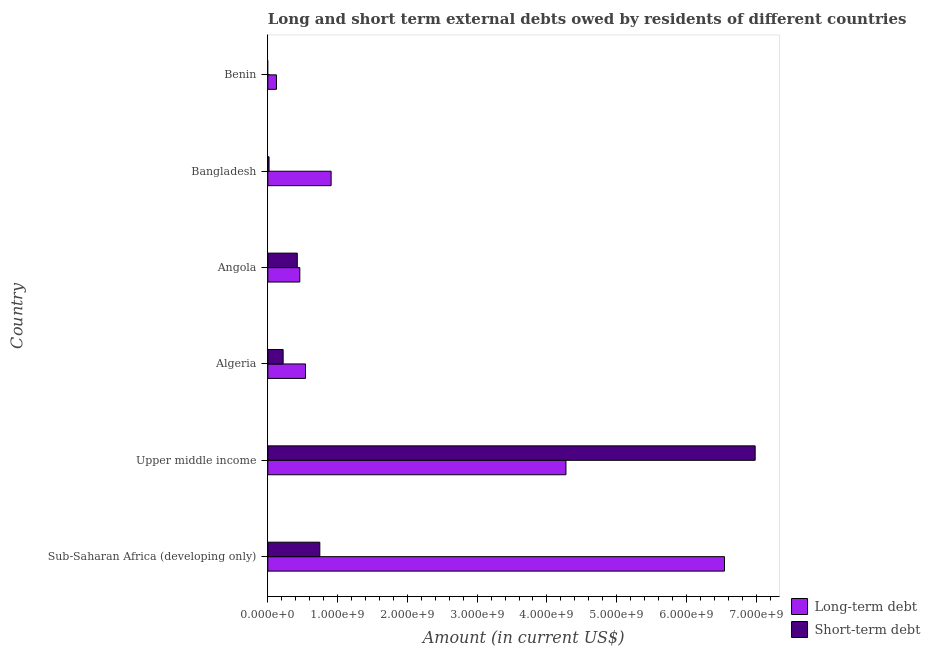How many different coloured bars are there?
Provide a short and direct response. 2. Are the number of bars per tick equal to the number of legend labels?
Make the answer very short. No. Are the number of bars on each tick of the Y-axis equal?
Your answer should be compact. No. How many bars are there on the 3rd tick from the bottom?
Provide a short and direct response. 2. What is the label of the 6th group of bars from the top?
Offer a very short reply. Sub-Saharan Africa (developing only). In how many cases, is the number of bars for a given country not equal to the number of legend labels?
Offer a terse response. 1. What is the short-term debts owed by residents in Angola?
Provide a short and direct response. 4.22e+08. Across all countries, what is the maximum short-term debts owed by residents?
Provide a succinct answer. 6.99e+09. Across all countries, what is the minimum long-term debts owed by residents?
Offer a terse response. 1.24e+08. In which country was the short-term debts owed by residents maximum?
Your response must be concise. Upper middle income. What is the total long-term debts owed by residents in the graph?
Provide a short and direct response. 1.28e+1. What is the difference between the long-term debts owed by residents in Bangladesh and that in Sub-Saharan Africa (developing only)?
Your response must be concise. -5.64e+09. What is the difference between the short-term debts owed by residents in Sub-Saharan Africa (developing only) and the long-term debts owed by residents in Benin?
Give a very brief answer. 6.21e+08. What is the average short-term debts owed by residents per country?
Make the answer very short. 1.40e+09. What is the difference between the long-term debts owed by residents and short-term debts owed by residents in Bangladesh?
Provide a short and direct response. 8.90e+08. What is the ratio of the long-term debts owed by residents in Bangladesh to that in Sub-Saharan Africa (developing only)?
Ensure brevity in your answer.  0.14. Is the difference between the long-term debts owed by residents in Angola and Bangladesh greater than the difference between the short-term debts owed by residents in Angola and Bangladesh?
Your answer should be very brief. No. What is the difference between the highest and the second highest short-term debts owed by residents?
Offer a very short reply. 6.24e+09. What is the difference between the highest and the lowest long-term debts owed by residents?
Offer a very short reply. 6.42e+09. In how many countries, is the short-term debts owed by residents greater than the average short-term debts owed by residents taken over all countries?
Ensure brevity in your answer.  1. Is the sum of the long-term debts owed by residents in Benin and Sub-Saharan Africa (developing only) greater than the maximum short-term debts owed by residents across all countries?
Your answer should be very brief. No. Are all the bars in the graph horizontal?
Your answer should be very brief. Yes. How many countries are there in the graph?
Offer a very short reply. 6. Does the graph contain any zero values?
Give a very brief answer. Yes. Where does the legend appear in the graph?
Make the answer very short. Bottom right. How many legend labels are there?
Your answer should be very brief. 2. What is the title of the graph?
Offer a very short reply. Long and short term external debts owed by residents of different countries. What is the Amount (in current US$) in Long-term debt in Sub-Saharan Africa (developing only)?
Give a very brief answer. 6.55e+09. What is the Amount (in current US$) in Short-term debt in Sub-Saharan Africa (developing only)?
Ensure brevity in your answer.  7.45e+08. What is the Amount (in current US$) of Long-term debt in Upper middle income?
Make the answer very short. 4.27e+09. What is the Amount (in current US$) in Short-term debt in Upper middle income?
Ensure brevity in your answer.  6.99e+09. What is the Amount (in current US$) in Long-term debt in Algeria?
Give a very brief answer. 5.39e+08. What is the Amount (in current US$) in Short-term debt in Algeria?
Your answer should be compact. 2.19e+08. What is the Amount (in current US$) in Long-term debt in Angola?
Make the answer very short. 4.58e+08. What is the Amount (in current US$) of Short-term debt in Angola?
Ensure brevity in your answer.  4.22e+08. What is the Amount (in current US$) in Long-term debt in Bangladesh?
Your answer should be compact. 9.07e+08. What is the Amount (in current US$) in Short-term debt in Bangladesh?
Offer a very short reply. 1.72e+07. What is the Amount (in current US$) in Long-term debt in Benin?
Offer a very short reply. 1.24e+08. What is the Amount (in current US$) in Short-term debt in Benin?
Make the answer very short. 0. Across all countries, what is the maximum Amount (in current US$) in Long-term debt?
Your answer should be compact. 6.55e+09. Across all countries, what is the maximum Amount (in current US$) in Short-term debt?
Your answer should be compact. 6.99e+09. Across all countries, what is the minimum Amount (in current US$) of Long-term debt?
Offer a very short reply. 1.24e+08. What is the total Amount (in current US$) of Long-term debt in the graph?
Keep it short and to the point. 1.28e+1. What is the total Amount (in current US$) in Short-term debt in the graph?
Your answer should be very brief. 8.39e+09. What is the difference between the Amount (in current US$) in Long-term debt in Sub-Saharan Africa (developing only) and that in Upper middle income?
Provide a short and direct response. 2.27e+09. What is the difference between the Amount (in current US$) of Short-term debt in Sub-Saharan Africa (developing only) and that in Upper middle income?
Offer a very short reply. -6.24e+09. What is the difference between the Amount (in current US$) in Long-term debt in Sub-Saharan Africa (developing only) and that in Algeria?
Give a very brief answer. 6.01e+09. What is the difference between the Amount (in current US$) of Short-term debt in Sub-Saharan Africa (developing only) and that in Algeria?
Give a very brief answer. 5.26e+08. What is the difference between the Amount (in current US$) in Long-term debt in Sub-Saharan Africa (developing only) and that in Angola?
Give a very brief answer. 6.09e+09. What is the difference between the Amount (in current US$) in Short-term debt in Sub-Saharan Africa (developing only) and that in Angola?
Your answer should be compact. 3.23e+08. What is the difference between the Amount (in current US$) of Long-term debt in Sub-Saharan Africa (developing only) and that in Bangladesh?
Your answer should be very brief. 5.64e+09. What is the difference between the Amount (in current US$) of Short-term debt in Sub-Saharan Africa (developing only) and that in Bangladesh?
Ensure brevity in your answer.  7.28e+08. What is the difference between the Amount (in current US$) of Long-term debt in Sub-Saharan Africa (developing only) and that in Benin?
Offer a very short reply. 6.42e+09. What is the difference between the Amount (in current US$) of Long-term debt in Upper middle income and that in Algeria?
Provide a succinct answer. 3.73e+09. What is the difference between the Amount (in current US$) in Short-term debt in Upper middle income and that in Algeria?
Offer a terse response. 6.77e+09. What is the difference between the Amount (in current US$) in Long-term debt in Upper middle income and that in Angola?
Offer a very short reply. 3.81e+09. What is the difference between the Amount (in current US$) in Short-term debt in Upper middle income and that in Angola?
Your answer should be compact. 6.56e+09. What is the difference between the Amount (in current US$) in Long-term debt in Upper middle income and that in Bangladesh?
Your answer should be compact. 3.37e+09. What is the difference between the Amount (in current US$) in Short-term debt in Upper middle income and that in Bangladesh?
Offer a terse response. 6.97e+09. What is the difference between the Amount (in current US$) of Long-term debt in Upper middle income and that in Benin?
Your answer should be compact. 4.15e+09. What is the difference between the Amount (in current US$) in Long-term debt in Algeria and that in Angola?
Your answer should be compact. 8.13e+07. What is the difference between the Amount (in current US$) in Short-term debt in Algeria and that in Angola?
Provide a short and direct response. -2.03e+08. What is the difference between the Amount (in current US$) in Long-term debt in Algeria and that in Bangladesh?
Offer a very short reply. -3.68e+08. What is the difference between the Amount (in current US$) in Short-term debt in Algeria and that in Bangladesh?
Make the answer very short. 2.02e+08. What is the difference between the Amount (in current US$) in Long-term debt in Algeria and that in Benin?
Give a very brief answer. 4.16e+08. What is the difference between the Amount (in current US$) in Long-term debt in Angola and that in Bangladesh?
Provide a short and direct response. -4.49e+08. What is the difference between the Amount (in current US$) in Short-term debt in Angola and that in Bangladesh?
Ensure brevity in your answer.  4.05e+08. What is the difference between the Amount (in current US$) in Long-term debt in Angola and that in Benin?
Keep it short and to the point. 3.35e+08. What is the difference between the Amount (in current US$) of Long-term debt in Bangladesh and that in Benin?
Provide a succinct answer. 7.83e+08. What is the difference between the Amount (in current US$) in Long-term debt in Sub-Saharan Africa (developing only) and the Amount (in current US$) in Short-term debt in Upper middle income?
Keep it short and to the point. -4.40e+08. What is the difference between the Amount (in current US$) of Long-term debt in Sub-Saharan Africa (developing only) and the Amount (in current US$) of Short-term debt in Algeria?
Make the answer very short. 6.33e+09. What is the difference between the Amount (in current US$) of Long-term debt in Sub-Saharan Africa (developing only) and the Amount (in current US$) of Short-term debt in Angola?
Provide a succinct answer. 6.12e+09. What is the difference between the Amount (in current US$) in Long-term debt in Sub-Saharan Africa (developing only) and the Amount (in current US$) in Short-term debt in Bangladesh?
Ensure brevity in your answer.  6.53e+09. What is the difference between the Amount (in current US$) in Long-term debt in Upper middle income and the Amount (in current US$) in Short-term debt in Algeria?
Your answer should be compact. 4.05e+09. What is the difference between the Amount (in current US$) of Long-term debt in Upper middle income and the Amount (in current US$) of Short-term debt in Angola?
Make the answer very short. 3.85e+09. What is the difference between the Amount (in current US$) of Long-term debt in Upper middle income and the Amount (in current US$) of Short-term debt in Bangladesh?
Make the answer very short. 4.26e+09. What is the difference between the Amount (in current US$) in Long-term debt in Algeria and the Amount (in current US$) in Short-term debt in Angola?
Provide a short and direct response. 1.17e+08. What is the difference between the Amount (in current US$) of Long-term debt in Algeria and the Amount (in current US$) of Short-term debt in Bangladesh?
Provide a short and direct response. 5.22e+08. What is the difference between the Amount (in current US$) in Long-term debt in Angola and the Amount (in current US$) in Short-term debt in Bangladesh?
Offer a very short reply. 4.41e+08. What is the average Amount (in current US$) in Long-term debt per country?
Offer a terse response. 2.14e+09. What is the average Amount (in current US$) in Short-term debt per country?
Offer a terse response. 1.40e+09. What is the difference between the Amount (in current US$) in Long-term debt and Amount (in current US$) in Short-term debt in Sub-Saharan Africa (developing only)?
Ensure brevity in your answer.  5.80e+09. What is the difference between the Amount (in current US$) in Long-term debt and Amount (in current US$) in Short-term debt in Upper middle income?
Provide a short and direct response. -2.71e+09. What is the difference between the Amount (in current US$) in Long-term debt and Amount (in current US$) in Short-term debt in Algeria?
Keep it short and to the point. 3.20e+08. What is the difference between the Amount (in current US$) in Long-term debt and Amount (in current US$) in Short-term debt in Angola?
Your response must be concise. 3.62e+07. What is the difference between the Amount (in current US$) in Long-term debt and Amount (in current US$) in Short-term debt in Bangladesh?
Keep it short and to the point. 8.90e+08. What is the ratio of the Amount (in current US$) in Long-term debt in Sub-Saharan Africa (developing only) to that in Upper middle income?
Your answer should be compact. 1.53. What is the ratio of the Amount (in current US$) of Short-term debt in Sub-Saharan Africa (developing only) to that in Upper middle income?
Offer a terse response. 0.11. What is the ratio of the Amount (in current US$) of Long-term debt in Sub-Saharan Africa (developing only) to that in Algeria?
Offer a terse response. 12.13. What is the ratio of the Amount (in current US$) in Short-term debt in Sub-Saharan Africa (developing only) to that in Algeria?
Provide a short and direct response. 3.4. What is the ratio of the Amount (in current US$) of Long-term debt in Sub-Saharan Africa (developing only) to that in Angola?
Give a very brief answer. 14.29. What is the ratio of the Amount (in current US$) in Short-term debt in Sub-Saharan Africa (developing only) to that in Angola?
Provide a short and direct response. 1.77. What is the ratio of the Amount (in current US$) in Long-term debt in Sub-Saharan Africa (developing only) to that in Bangladesh?
Provide a short and direct response. 7.22. What is the ratio of the Amount (in current US$) of Short-term debt in Sub-Saharan Africa (developing only) to that in Bangladesh?
Offer a terse response. 43.39. What is the ratio of the Amount (in current US$) of Long-term debt in Sub-Saharan Africa (developing only) to that in Benin?
Keep it short and to the point. 52.98. What is the ratio of the Amount (in current US$) of Long-term debt in Upper middle income to that in Algeria?
Offer a terse response. 7.92. What is the ratio of the Amount (in current US$) of Short-term debt in Upper middle income to that in Algeria?
Offer a terse response. 31.87. What is the ratio of the Amount (in current US$) in Long-term debt in Upper middle income to that in Angola?
Ensure brevity in your answer.  9.33. What is the ratio of the Amount (in current US$) of Short-term debt in Upper middle income to that in Angola?
Make the answer very short. 16.55. What is the ratio of the Amount (in current US$) in Long-term debt in Upper middle income to that in Bangladesh?
Keep it short and to the point. 4.71. What is the ratio of the Amount (in current US$) in Short-term debt in Upper middle income to that in Bangladesh?
Make the answer very short. 406.82. What is the ratio of the Amount (in current US$) of Long-term debt in Upper middle income to that in Benin?
Provide a short and direct response. 34.59. What is the ratio of the Amount (in current US$) of Long-term debt in Algeria to that in Angola?
Offer a terse response. 1.18. What is the ratio of the Amount (in current US$) of Short-term debt in Algeria to that in Angola?
Offer a very short reply. 0.52. What is the ratio of the Amount (in current US$) in Long-term debt in Algeria to that in Bangladesh?
Make the answer very short. 0.59. What is the ratio of the Amount (in current US$) of Short-term debt in Algeria to that in Bangladesh?
Make the answer very short. 12.77. What is the ratio of the Amount (in current US$) of Long-term debt in Algeria to that in Benin?
Give a very brief answer. 4.37. What is the ratio of the Amount (in current US$) of Long-term debt in Angola to that in Bangladesh?
Your response must be concise. 0.51. What is the ratio of the Amount (in current US$) of Short-term debt in Angola to that in Bangladesh?
Make the answer very short. 24.58. What is the ratio of the Amount (in current US$) in Long-term debt in Angola to that in Benin?
Your answer should be very brief. 3.71. What is the ratio of the Amount (in current US$) of Long-term debt in Bangladesh to that in Benin?
Keep it short and to the point. 7.34. What is the difference between the highest and the second highest Amount (in current US$) in Long-term debt?
Make the answer very short. 2.27e+09. What is the difference between the highest and the second highest Amount (in current US$) of Short-term debt?
Your response must be concise. 6.24e+09. What is the difference between the highest and the lowest Amount (in current US$) of Long-term debt?
Provide a short and direct response. 6.42e+09. What is the difference between the highest and the lowest Amount (in current US$) of Short-term debt?
Offer a very short reply. 6.99e+09. 